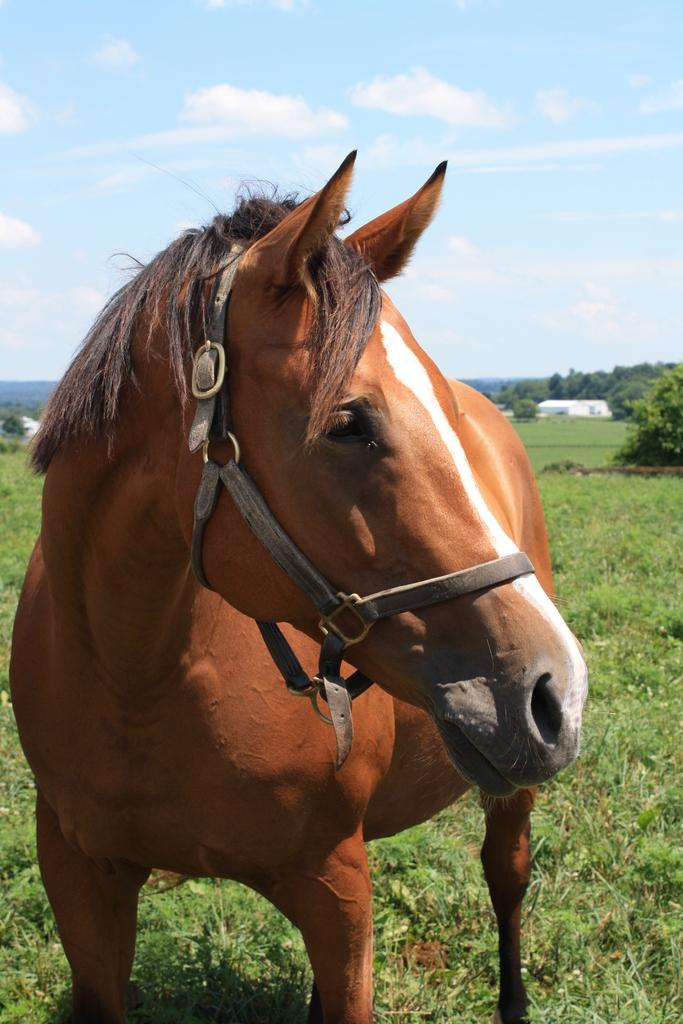What type of animal is in the image? There is a brown horse in the image. What can be seen in the background of the image? There are trees and buildings in the background of the image. What is the condition of the sky in the image? The sky is cloudy in the image. What type of vegetation is on the ground in the image? There are plants and grass on the ground in the image. What type of beef is being prepared in the image? There is no beef or any indication of food preparation in the image; it features a brown horse with a background of trees, buildings, and a cloudy sky. 